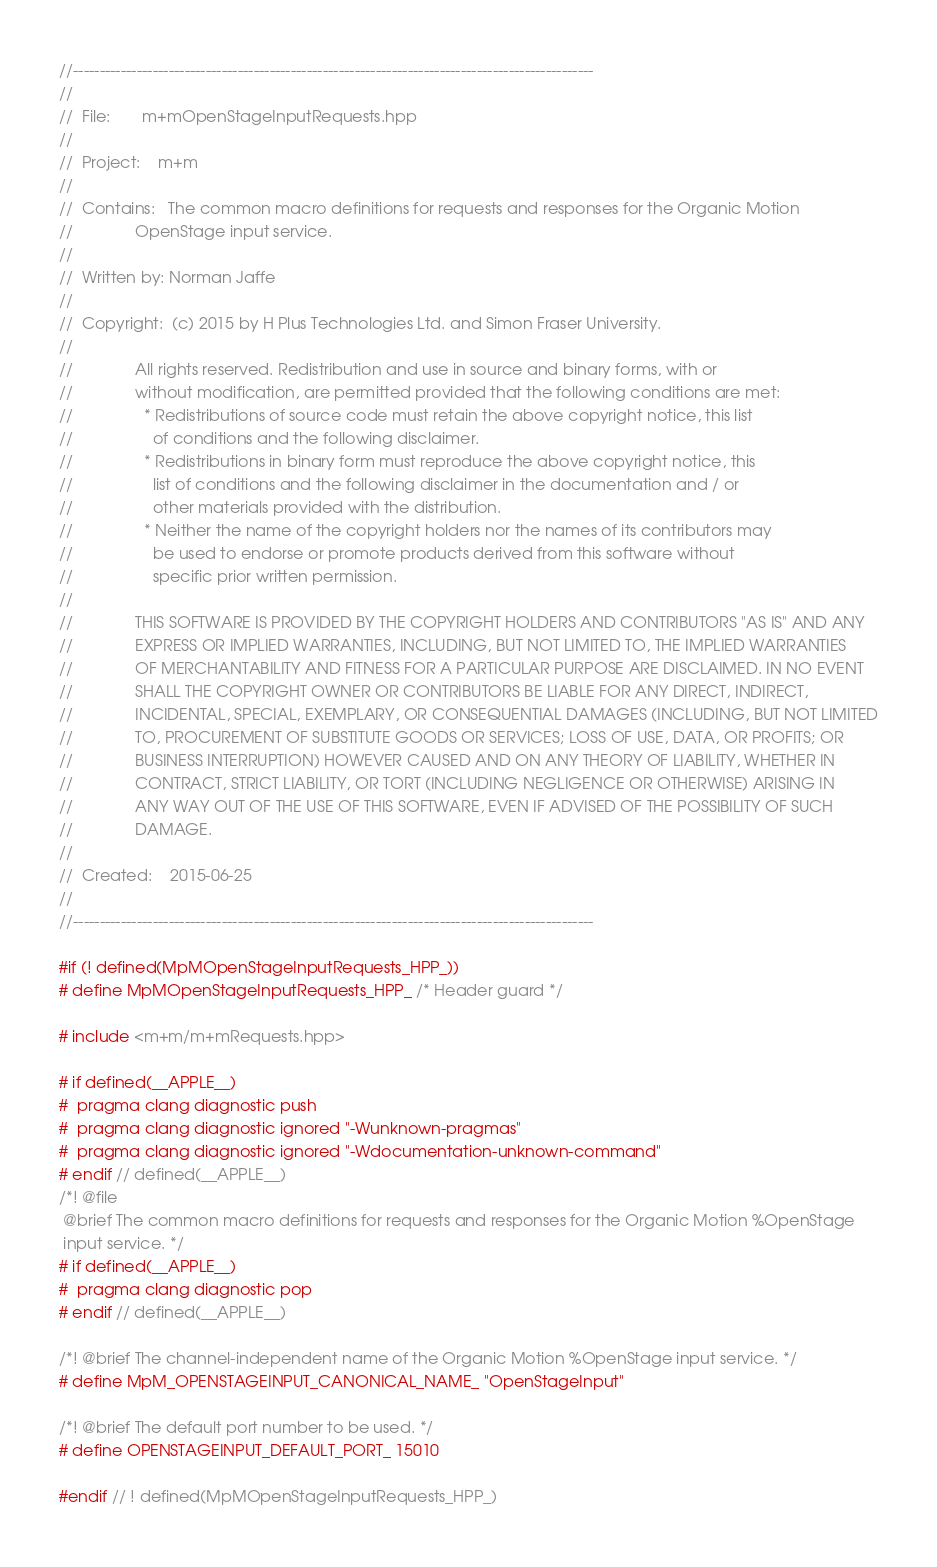Convert code to text. <code><loc_0><loc_0><loc_500><loc_500><_C++_>//--------------------------------------------------------------------------------------------------
//
//  File:       m+mOpenStageInputRequests.hpp
//
//  Project:    m+m
//
//  Contains:   The common macro definitions for requests and responses for the Organic Motion
//              OpenStage input service.
//
//  Written by: Norman Jaffe
//
//  Copyright:  (c) 2015 by H Plus Technologies Ltd. and Simon Fraser University.
//
//              All rights reserved. Redistribution and use in source and binary forms, with or
//              without modification, are permitted provided that the following conditions are met:
//                * Redistributions of source code must retain the above copyright notice, this list
//                  of conditions and the following disclaimer.
//                * Redistributions in binary form must reproduce the above copyright notice, this
//                  list of conditions and the following disclaimer in the documentation and / or
//                  other materials provided with the distribution.
//                * Neither the name of the copyright holders nor the names of its contributors may
//                  be used to endorse or promote products derived from this software without
//                  specific prior written permission.
//
//              THIS SOFTWARE IS PROVIDED BY THE COPYRIGHT HOLDERS AND CONTRIBUTORS "AS IS" AND ANY
//              EXPRESS OR IMPLIED WARRANTIES, INCLUDING, BUT NOT LIMITED TO, THE IMPLIED WARRANTIES
//              OF MERCHANTABILITY AND FITNESS FOR A PARTICULAR PURPOSE ARE DISCLAIMED. IN NO EVENT
//              SHALL THE COPYRIGHT OWNER OR CONTRIBUTORS BE LIABLE FOR ANY DIRECT, INDIRECT,
//              INCIDENTAL, SPECIAL, EXEMPLARY, OR CONSEQUENTIAL DAMAGES (INCLUDING, BUT NOT LIMITED
//              TO, PROCUREMENT OF SUBSTITUTE GOODS OR SERVICES; LOSS OF USE, DATA, OR PROFITS; OR
//              BUSINESS INTERRUPTION) HOWEVER CAUSED AND ON ANY THEORY OF LIABILITY, WHETHER IN
//              CONTRACT, STRICT LIABILITY, OR TORT (INCLUDING NEGLIGENCE OR OTHERWISE) ARISING IN
//              ANY WAY OUT OF THE USE OF THIS SOFTWARE, EVEN IF ADVISED OF THE POSSIBILITY OF SUCH
//              DAMAGE.
//
//  Created:    2015-06-25
//
//--------------------------------------------------------------------------------------------------

#if (! defined(MpMOpenStageInputRequests_HPP_))
# define MpMOpenStageInputRequests_HPP_ /* Header guard */

# include <m+m/m+mRequests.hpp>

# if defined(__APPLE__)
#  pragma clang diagnostic push
#  pragma clang diagnostic ignored "-Wunknown-pragmas"
#  pragma clang diagnostic ignored "-Wdocumentation-unknown-command"
# endif // defined(__APPLE__)
/*! @file
 @brief The common macro definitions for requests and responses for the Organic Motion %OpenStage
 input service. */
# if defined(__APPLE__)
#  pragma clang diagnostic pop
# endif // defined(__APPLE__)

/*! @brief The channel-independent name of the Organic Motion %OpenStage input service. */
# define MpM_OPENSTAGEINPUT_CANONICAL_NAME_ "OpenStageInput"

/*! @brief The default port number to be used. */
# define OPENSTAGEINPUT_DEFAULT_PORT_ 15010

#endif // ! defined(MpMOpenStageInputRequests_HPP_)
</code> 